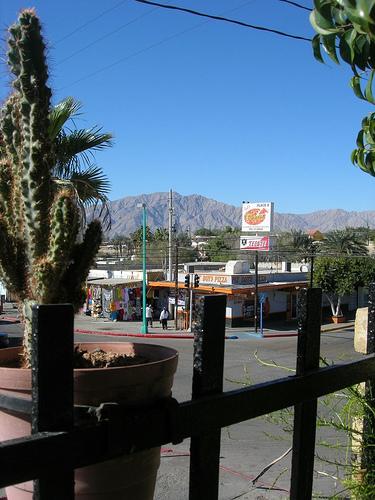What kind of plant is on the left?
Short answer required. Cactus. How do we know this scene is in the west?
Answer briefly. Cactus. Is it snowing?
Give a very brief answer. No. 